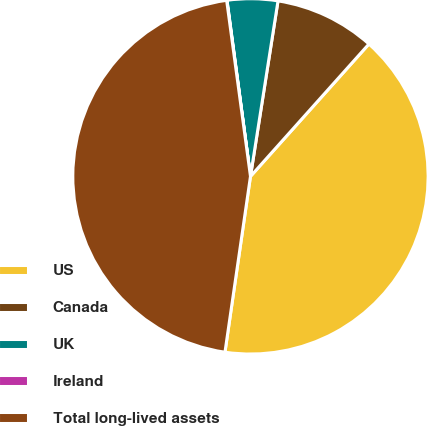Convert chart. <chart><loc_0><loc_0><loc_500><loc_500><pie_chart><fcel>US<fcel>Canada<fcel>UK<fcel>Ireland<fcel>Total long-lived assets<nl><fcel>40.68%<fcel>9.14%<fcel>4.59%<fcel>0.03%<fcel>45.57%<nl></chart> 